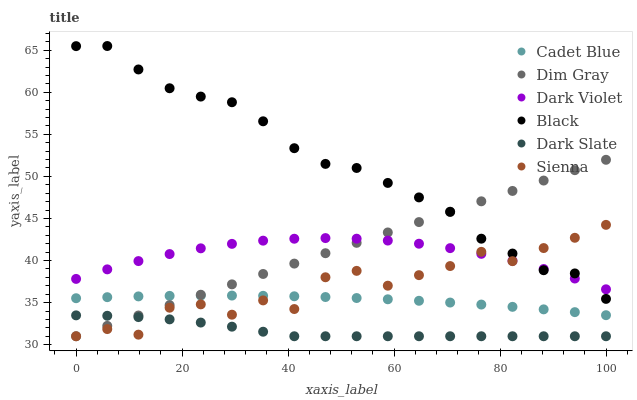Does Dark Slate have the minimum area under the curve?
Answer yes or no. Yes. Does Black have the maximum area under the curve?
Answer yes or no. Yes. Does Dark Violet have the minimum area under the curve?
Answer yes or no. No. Does Dark Violet have the maximum area under the curve?
Answer yes or no. No. Is Dim Gray the smoothest?
Answer yes or no. Yes. Is Sienna the roughest?
Answer yes or no. Yes. Is Dark Violet the smoothest?
Answer yes or no. No. Is Dark Violet the roughest?
Answer yes or no. No. Does Dim Gray have the lowest value?
Answer yes or no. Yes. Does Dark Violet have the lowest value?
Answer yes or no. No. Does Black have the highest value?
Answer yes or no. Yes. Does Dark Violet have the highest value?
Answer yes or no. No. Is Dark Slate less than Black?
Answer yes or no. Yes. Is Dark Violet greater than Cadet Blue?
Answer yes or no. Yes. Does Sienna intersect Cadet Blue?
Answer yes or no. Yes. Is Sienna less than Cadet Blue?
Answer yes or no. No. Is Sienna greater than Cadet Blue?
Answer yes or no. No. Does Dark Slate intersect Black?
Answer yes or no. No. 